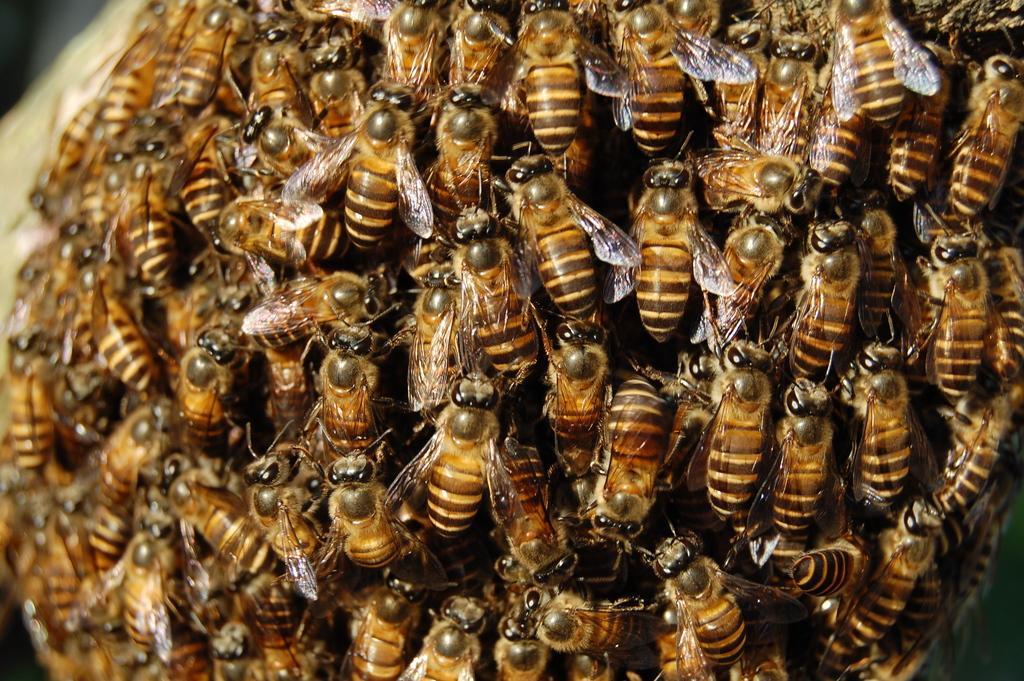Please provide a concise description of this image. In this image we can see group of insects. 